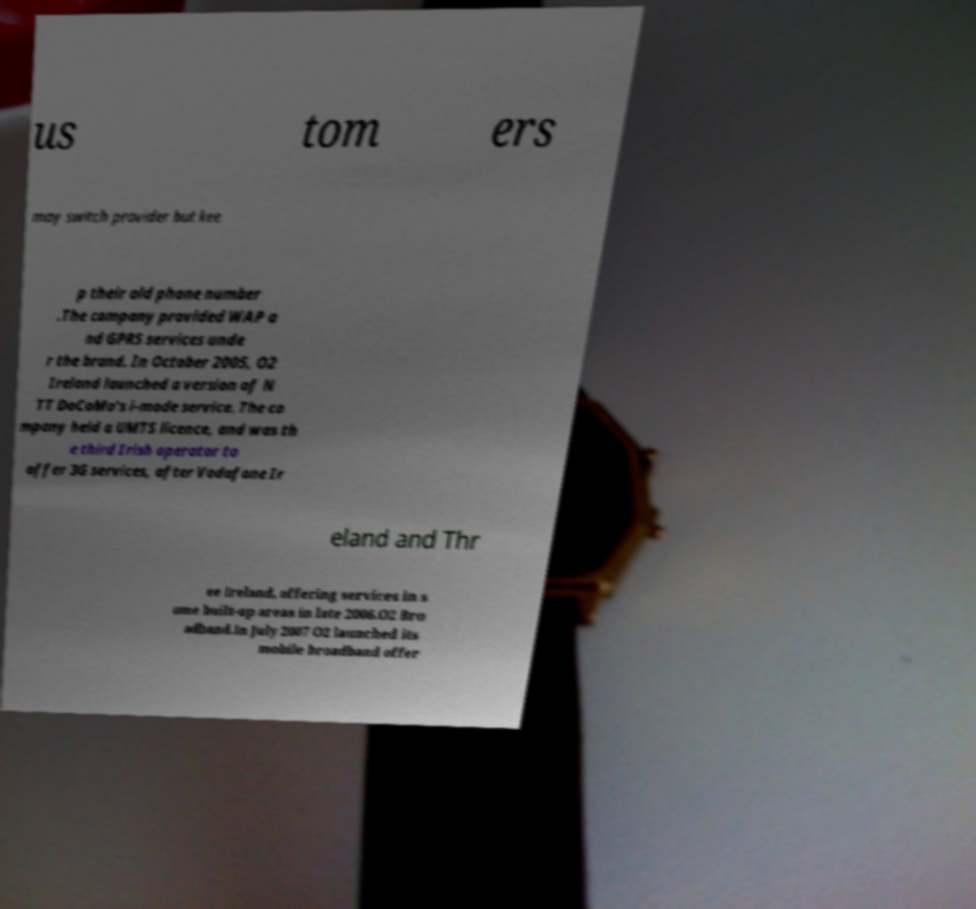Can you accurately transcribe the text from the provided image for me? us tom ers may switch provider but kee p their old phone number .The company provided WAP a nd GPRS services unde r the brand. In October 2005, O2 Ireland launched a version of N TT DoCoMo's i-mode service. The co mpany held a UMTS licence, and was th e third Irish operator to offer 3G services, after Vodafone Ir eland and Thr ee Ireland, offering services in s ome built-up areas in late 2006.O2 Bro adband.In July 2007 O2 launched its mobile broadband offer 